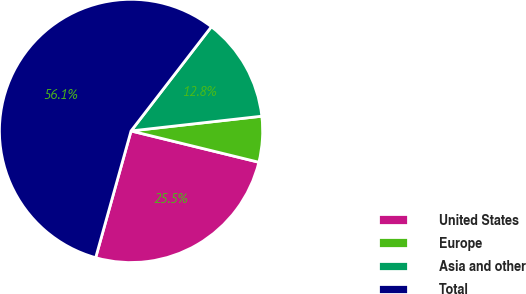Convert chart. <chart><loc_0><loc_0><loc_500><loc_500><pie_chart><fcel>United States<fcel>Europe<fcel>Asia and other<fcel>Total<nl><fcel>25.51%<fcel>5.61%<fcel>12.76%<fcel>56.12%<nl></chart> 